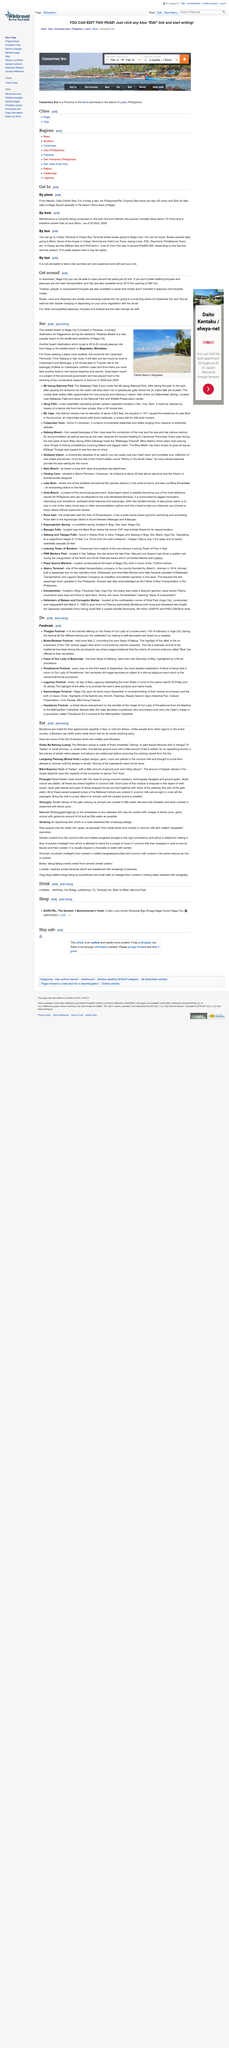Give some essential details in this illustration. Yes, it is possible to explore the downtown area of Naga City on foot, as stated in the article "Get around. Ground pork is a common ingredient added to the recipe for Gulay Na Natong (Laing), a popular Filipino dish. In Carmarines Sur and Taxias, the primary modes of transportation used for travel are buses, vans, and Jeepneys, which are the most commonly utilized forms of transportation. Maintenance activities are currently in progress on the train line originating from Manila. Gulay Na Natong (Laing) is a recipe that includes natong or gabi leaves as an ingredient. 